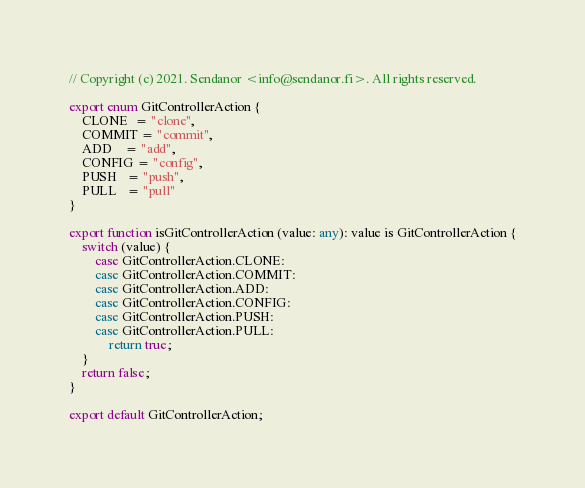Convert code to text. <code><loc_0><loc_0><loc_500><loc_500><_TypeScript_>// Copyright (c) 2021. Sendanor <info@sendanor.fi>. All rights reserved.

export enum GitControllerAction {
    CLONE  = "clone",
    COMMIT = "commit",
    ADD    = "add",
    CONFIG = "config",
    PUSH   = "push",
    PULL   = "pull"
}

export function isGitControllerAction (value: any): value is GitControllerAction {
    switch (value) {
        case GitControllerAction.CLONE:
        case GitControllerAction.COMMIT:
        case GitControllerAction.ADD:
        case GitControllerAction.CONFIG:
        case GitControllerAction.PUSH:
        case GitControllerAction.PULL:
            return true;
    }
    return false;
}

export default GitControllerAction;
</code> 